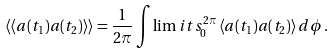Convert formula to latex. <formula><loc_0><loc_0><loc_500><loc_500>\left \langle \left \langle a ( t _ { 1 } ) a ( t _ { 2 } ) \right \rangle \right \rangle = \frac { 1 } { 2 \pi } \int \lim i t s _ { 0 } ^ { 2 \pi } \left \langle a ( t _ { 1 } ) a ( t _ { 2 } ) \right \rangle d \phi \, .</formula> 